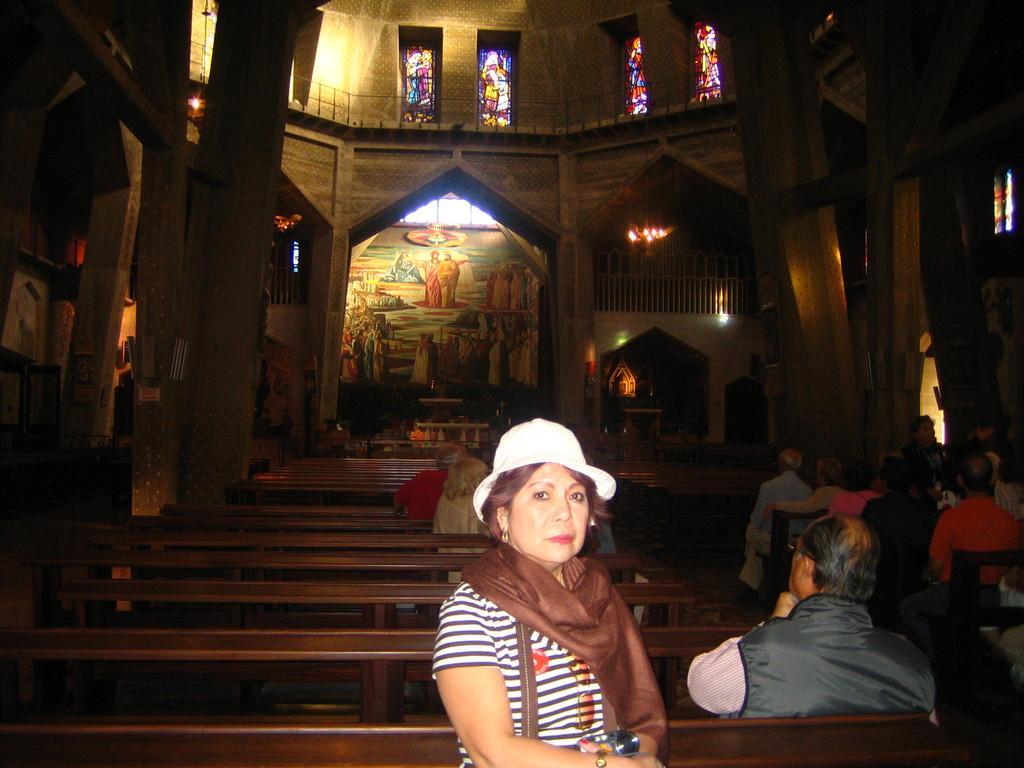In one or two sentences, can you explain what this image depicts? Picture inside of a building. These are windows and pillars. People are sitting on benches. Painting is on the wall. 